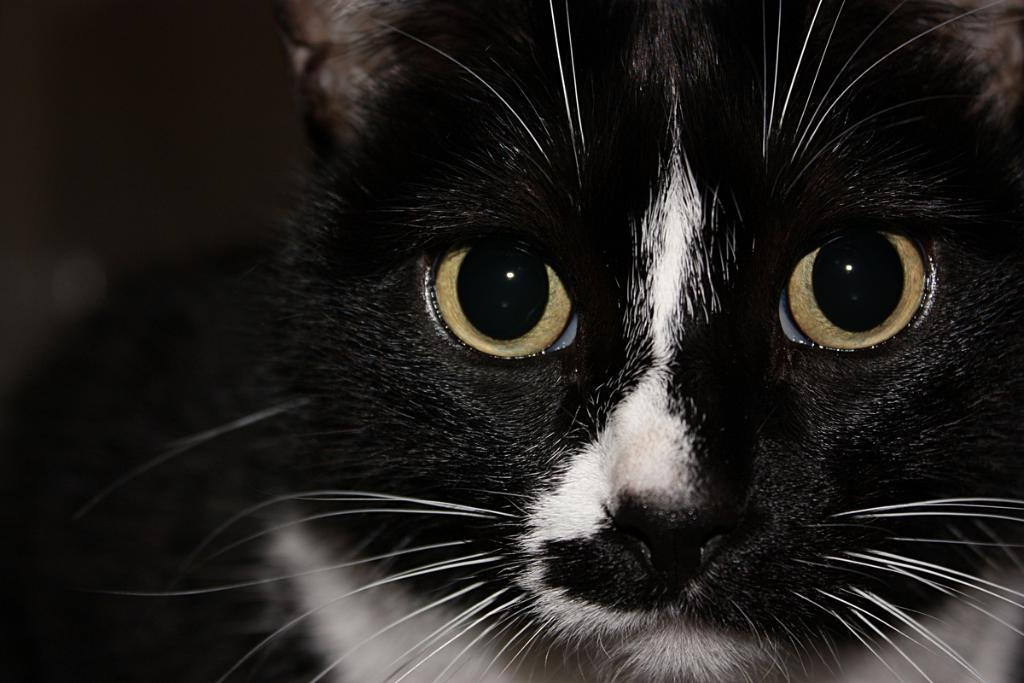What type of animal is in the image? There is a cat in the image. Can you describe the background of the image? The background of the image is blurred. What type of cabbage is being used as a shock absorber in the image? There is no cabbage or shock absorber present in the image; it features a cat with a blurred background. 